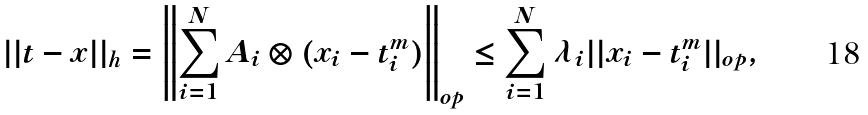Convert formula to latex. <formula><loc_0><loc_0><loc_500><loc_500>| | t - x | | _ { h } & = \left \| \sum _ { i = 1 } ^ { N } A _ { i } \otimes ( x _ { i } - t _ { i } ^ { m } ) \right \| _ { o p } \leq \sum _ { i = 1 } ^ { N } \lambda _ { i } | | x _ { i } - t _ { i } ^ { m } | | _ { o p } ,</formula> 